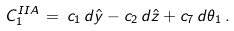Convert formula to latex. <formula><loc_0><loc_0><loc_500><loc_500>C _ { 1 } ^ { I I A } \, = \, c _ { 1 } \, d \hat { y } - c _ { 2 } \, d \hat { z } + c _ { 7 } \, d \theta _ { 1 } \, .</formula> 